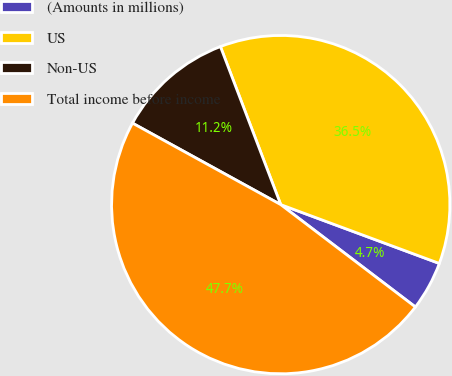<chart> <loc_0><loc_0><loc_500><loc_500><pie_chart><fcel>(Amounts in millions)<fcel>US<fcel>Non-US<fcel>Total income before income<nl><fcel>4.69%<fcel>36.46%<fcel>11.2%<fcel>47.66%<nl></chart> 